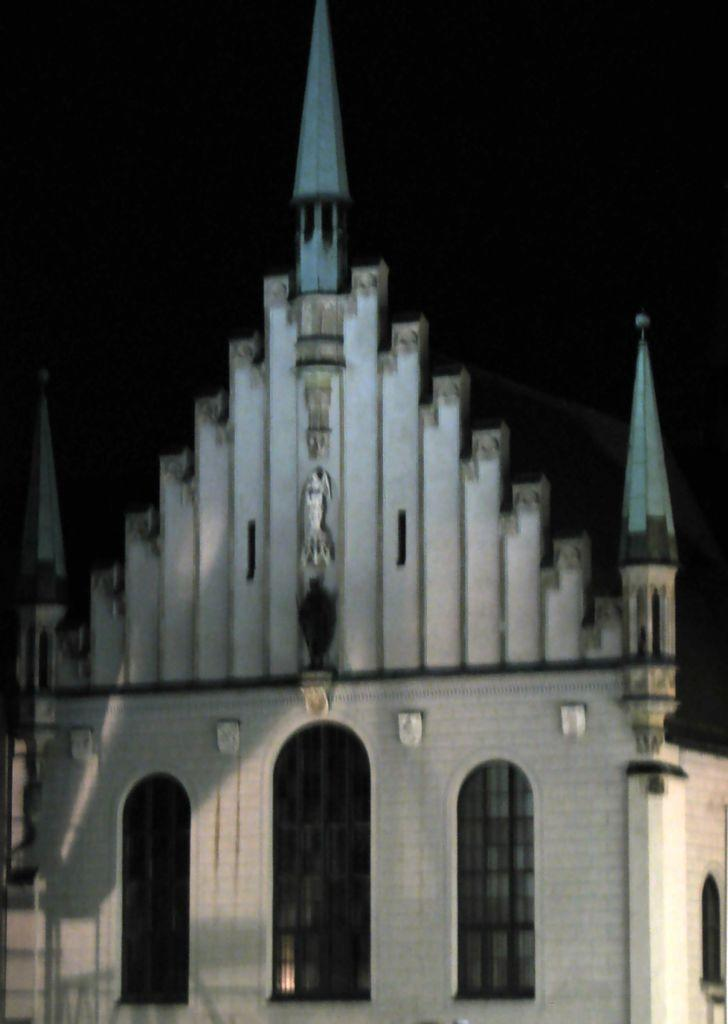What is the main subject in the center of the image? There is a building in the center of the image. What can be seen in the background of the image? The sky is visible in the background of the image. What type of honey is being used for treatment in the image? There is no honey or treatment present in the image; it only features a building and the sky. 